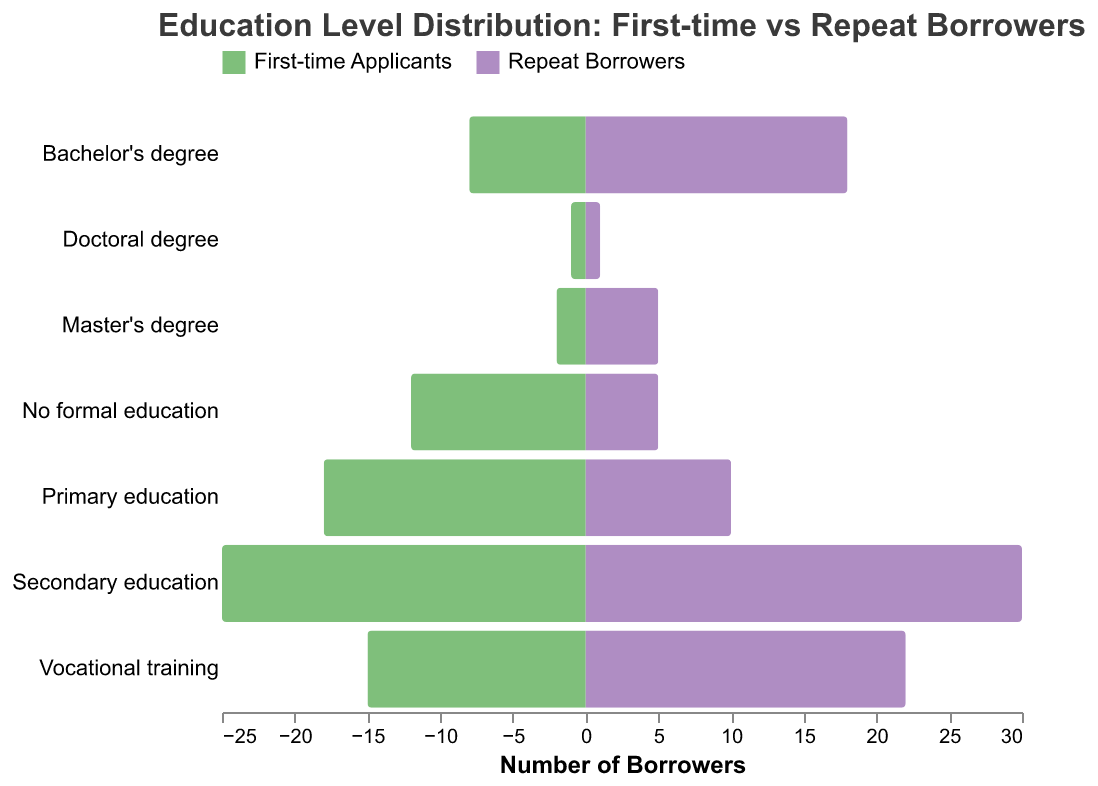What is the title of the chart? The title is usually placed at the top of the chart and clearly describes its content. The given chart title reads "Education Level Distribution: First-time vs Repeat Borrowers."
Answer: Education Level Distribution: First-time vs Repeat Borrowers Which education level has the highest number of repeat borrowers? By looking at the maroon-colored bars that represent repeat borrowers, the tallest bar corresponds to "Secondary education." This indicates that the highest number of repeat borrowers have a secondary education.
Answer: Secondary education How many repeat borrowers have a bachelor's degree? The chart includes tooltip information for each bar. By referencing the bar associated with "Bachelor's degree" and the maroon color, it shows 18 repeat borrowers.
Answer: 18 Which group has more borrowers with primary education? Comparing the green bar (First-time Applicants) and the maroon bar (Repeat Borrowers) at the "Primary education" level, the green bar is taller. First-time applicants have more borrowers with primary education.
Answer: First-time Applicants What is the total number of borrowers with vocational training? Adding the number of first-time applicants with those of repeat borrowers in "Vocational training" (15 + 22), we get 37.
Answer: 37 What is the difference in the number of secondary education holders between first-time applicants and repeat borrowers? For "Secondary education," the number of first-time applicants is 25, and the number of repeat borrowers is 30. Subtracting these gives us the difference (30 - 25) = 5.
Answer: 5 How does the number of master's degree holders compare between first-time applicants and repeat borrowers? For "Master's degree," the count for first-time applicants is 2 and for repeat borrowers is 5. Comparing these, repeat borrowers have more master's degree holders.
Answer: Repeat borrowers have more Which education level shows the smallest difference between first-time applicants and repeat borrowers? By visually comparing the difference in bar lengths for each education level, the "Doctoral degree" group, with 1 each, shows the smallest difference.
Answer: Doctoral degree What is the ratio of first-time applicants to repeat borrowers with no formal education? For "No formal education," the counts are 12 (first-time) and 5 (repeat). The ratio is calculated as 12/5 = 2.4.
Answer: 2.4 Identify an education level where the number of first-time applicants is less than that of repeat borrowers. By comparing the lengths of the bars, "Secondary education," "Vocational training," "Bachelor's degree," and "Master's degree" show that repeat borrowers exceed first-time applicants.
Answer: Secondary education, Vocational training, Bachelor's degree, Master's degree 